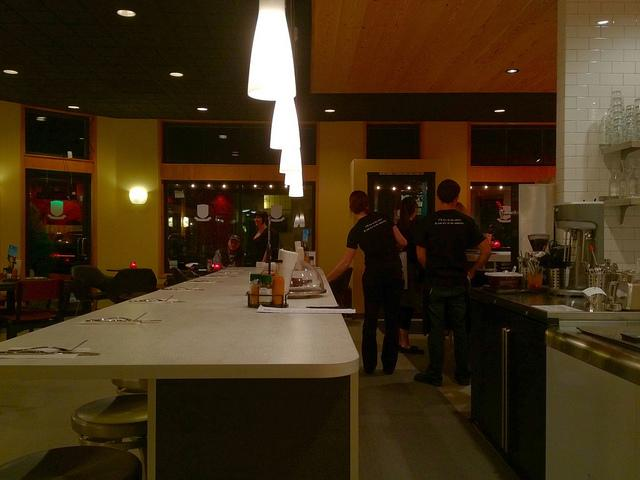What type of counter is shown?

Choices:
A) check-out
B) kitchen
C) bathroom
D) restaurant restaurant 